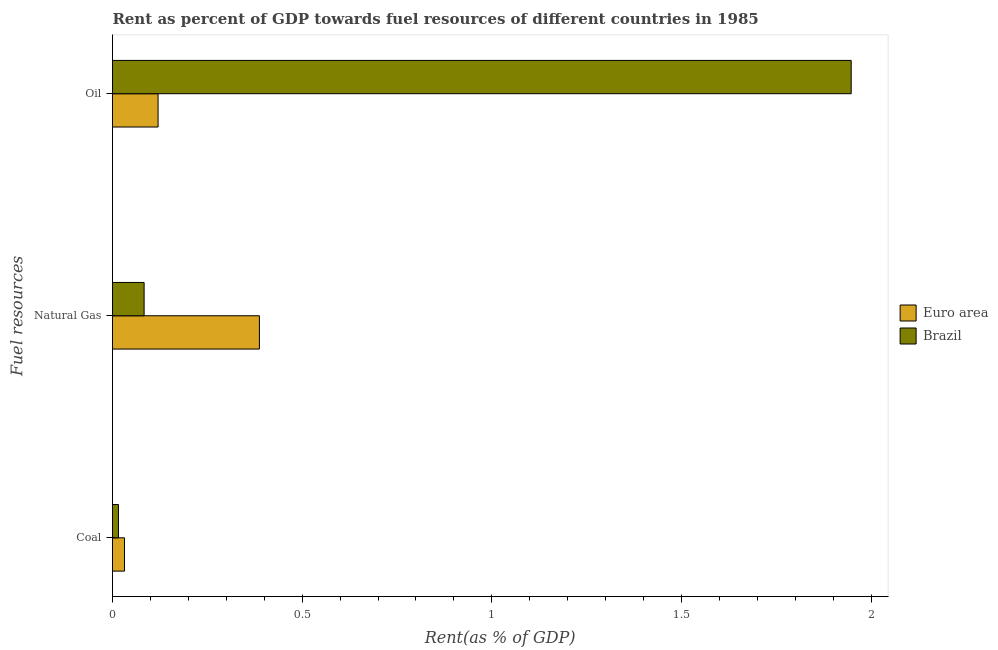Are the number of bars per tick equal to the number of legend labels?
Make the answer very short. Yes. Are the number of bars on each tick of the Y-axis equal?
Your response must be concise. Yes. How many bars are there on the 2nd tick from the top?
Provide a short and direct response. 2. How many bars are there on the 1st tick from the bottom?
Provide a succinct answer. 2. What is the label of the 2nd group of bars from the top?
Keep it short and to the point. Natural Gas. What is the rent towards coal in Euro area?
Offer a very short reply. 0.03. Across all countries, what is the maximum rent towards coal?
Your answer should be very brief. 0.03. Across all countries, what is the minimum rent towards natural gas?
Offer a terse response. 0.08. In which country was the rent towards coal maximum?
Offer a terse response. Euro area. What is the total rent towards oil in the graph?
Ensure brevity in your answer.  2.07. What is the difference between the rent towards oil in Brazil and that in Euro area?
Ensure brevity in your answer.  1.83. What is the difference between the rent towards natural gas in Euro area and the rent towards oil in Brazil?
Offer a very short reply. -1.56. What is the average rent towards natural gas per country?
Your answer should be very brief. 0.24. What is the difference between the rent towards oil and rent towards coal in Brazil?
Make the answer very short. 1.93. In how many countries, is the rent towards natural gas greater than 0.1 %?
Offer a terse response. 1. What is the ratio of the rent towards natural gas in Euro area to that in Brazil?
Your answer should be compact. 4.65. Is the rent towards natural gas in Brazil less than that in Euro area?
Offer a very short reply. Yes. What is the difference between the highest and the second highest rent towards oil?
Keep it short and to the point. 1.83. What is the difference between the highest and the lowest rent towards oil?
Make the answer very short. 1.83. In how many countries, is the rent towards coal greater than the average rent towards coal taken over all countries?
Provide a succinct answer. 1. What does the 1st bar from the top in Natural Gas represents?
Keep it short and to the point. Brazil. Is it the case that in every country, the sum of the rent towards coal and rent towards natural gas is greater than the rent towards oil?
Your response must be concise. No. How many bars are there?
Offer a very short reply. 6. Are all the bars in the graph horizontal?
Give a very brief answer. Yes. How many countries are there in the graph?
Give a very brief answer. 2. What is the difference between two consecutive major ticks on the X-axis?
Provide a succinct answer. 0.5. Are the values on the major ticks of X-axis written in scientific E-notation?
Offer a very short reply. No. Does the graph contain any zero values?
Offer a terse response. No. How many legend labels are there?
Provide a short and direct response. 2. How are the legend labels stacked?
Your answer should be compact. Vertical. What is the title of the graph?
Keep it short and to the point. Rent as percent of GDP towards fuel resources of different countries in 1985. Does "Greece" appear as one of the legend labels in the graph?
Your response must be concise. No. What is the label or title of the X-axis?
Your response must be concise. Rent(as % of GDP). What is the label or title of the Y-axis?
Keep it short and to the point. Fuel resources. What is the Rent(as % of GDP) of Euro area in Coal?
Give a very brief answer. 0.03. What is the Rent(as % of GDP) of Brazil in Coal?
Your answer should be compact. 0.02. What is the Rent(as % of GDP) in Euro area in Natural Gas?
Ensure brevity in your answer.  0.39. What is the Rent(as % of GDP) in Brazil in Natural Gas?
Provide a succinct answer. 0.08. What is the Rent(as % of GDP) of Euro area in Oil?
Make the answer very short. 0.12. What is the Rent(as % of GDP) of Brazil in Oil?
Offer a very short reply. 1.95. Across all Fuel resources, what is the maximum Rent(as % of GDP) in Euro area?
Ensure brevity in your answer.  0.39. Across all Fuel resources, what is the maximum Rent(as % of GDP) of Brazil?
Your answer should be compact. 1.95. Across all Fuel resources, what is the minimum Rent(as % of GDP) in Euro area?
Offer a very short reply. 0.03. Across all Fuel resources, what is the minimum Rent(as % of GDP) of Brazil?
Your response must be concise. 0.02. What is the total Rent(as % of GDP) of Euro area in the graph?
Provide a short and direct response. 0.54. What is the total Rent(as % of GDP) in Brazil in the graph?
Provide a short and direct response. 2.05. What is the difference between the Rent(as % of GDP) of Euro area in Coal and that in Natural Gas?
Your answer should be very brief. -0.36. What is the difference between the Rent(as % of GDP) of Brazil in Coal and that in Natural Gas?
Ensure brevity in your answer.  -0.07. What is the difference between the Rent(as % of GDP) of Euro area in Coal and that in Oil?
Provide a short and direct response. -0.09. What is the difference between the Rent(as % of GDP) of Brazil in Coal and that in Oil?
Give a very brief answer. -1.93. What is the difference between the Rent(as % of GDP) in Euro area in Natural Gas and that in Oil?
Keep it short and to the point. 0.27. What is the difference between the Rent(as % of GDP) of Brazil in Natural Gas and that in Oil?
Your answer should be compact. -1.86. What is the difference between the Rent(as % of GDP) in Euro area in Coal and the Rent(as % of GDP) in Brazil in Natural Gas?
Provide a short and direct response. -0.05. What is the difference between the Rent(as % of GDP) in Euro area in Coal and the Rent(as % of GDP) in Brazil in Oil?
Ensure brevity in your answer.  -1.92. What is the difference between the Rent(as % of GDP) of Euro area in Natural Gas and the Rent(as % of GDP) of Brazil in Oil?
Offer a very short reply. -1.56. What is the average Rent(as % of GDP) in Euro area per Fuel resources?
Keep it short and to the point. 0.18. What is the average Rent(as % of GDP) of Brazil per Fuel resources?
Provide a succinct answer. 0.68. What is the difference between the Rent(as % of GDP) of Euro area and Rent(as % of GDP) of Brazil in Coal?
Offer a very short reply. 0.02. What is the difference between the Rent(as % of GDP) of Euro area and Rent(as % of GDP) of Brazil in Natural Gas?
Ensure brevity in your answer.  0.3. What is the difference between the Rent(as % of GDP) of Euro area and Rent(as % of GDP) of Brazil in Oil?
Provide a short and direct response. -1.83. What is the ratio of the Rent(as % of GDP) in Euro area in Coal to that in Natural Gas?
Offer a very short reply. 0.08. What is the ratio of the Rent(as % of GDP) of Brazil in Coal to that in Natural Gas?
Offer a very short reply. 0.19. What is the ratio of the Rent(as % of GDP) of Euro area in Coal to that in Oil?
Ensure brevity in your answer.  0.26. What is the ratio of the Rent(as % of GDP) in Brazil in Coal to that in Oil?
Your answer should be very brief. 0.01. What is the ratio of the Rent(as % of GDP) of Euro area in Natural Gas to that in Oil?
Your answer should be compact. 3.22. What is the ratio of the Rent(as % of GDP) in Brazil in Natural Gas to that in Oil?
Make the answer very short. 0.04. What is the difference between the highest and the second highest Rent(as % of GDP) of Euro area?
Give a very brief answer. 0.27. What is the difference between the highest and the second highest Rent(as % of GDP) in Brazil?
Your answer should be compact. 1.86. What is the difference between the highest and the lowest Rent(as % of GDP) in Euro area?
Your answer should be very brief. 0.36. What is the difference between the highest and the lowest Rent(as % of GDP) in Brazil?
Give a very brief answer. 1.93. 